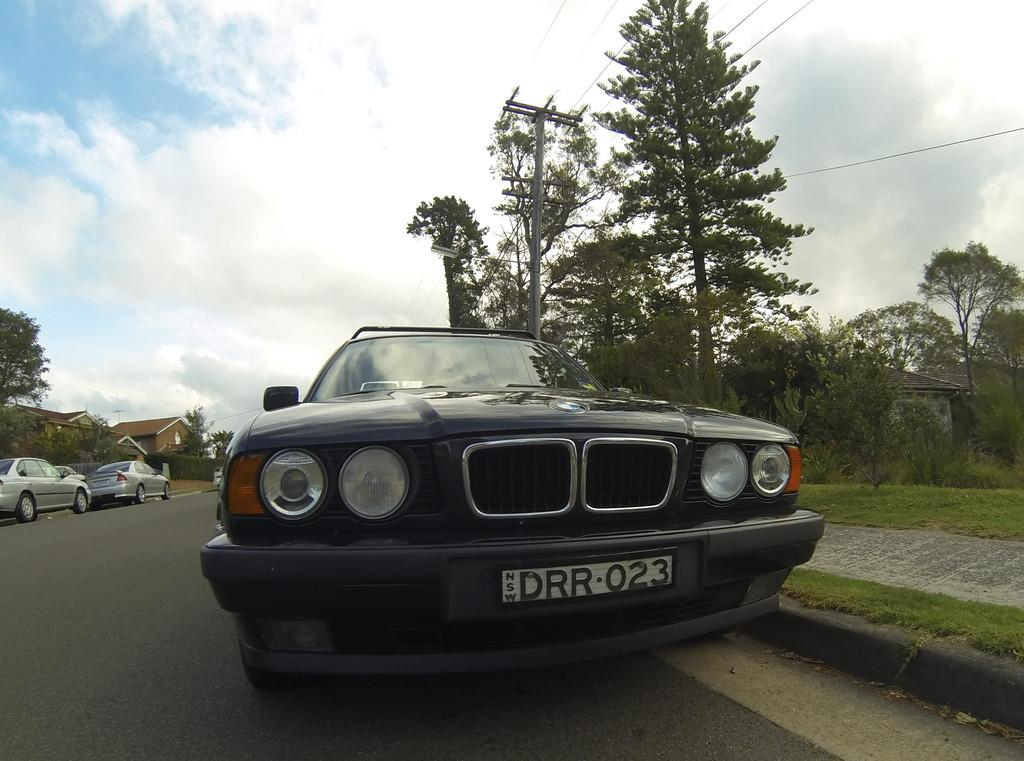What type of vehicles can be seen in the image? There are cars in the image. What type of vegetation is present in the image? There is grass, plants, and trees in the image. What type of structures are visible in the image? There are houses in the image. What type of pathway is present in the image? There is a road in the image. What can be seen in the background of the image? The sky is visible in the background of the image, and there are clouds in the sky. Can you tell me how many keys are hanging from the trees in the image? There are no keys present in the image; it features cars, grass, plants, houses, a road, trees, and a sky with clouds. Is the father of the person who took the image visible in the image? There is no information about the person who took the image or their father, so it cannot be determined from the image. 